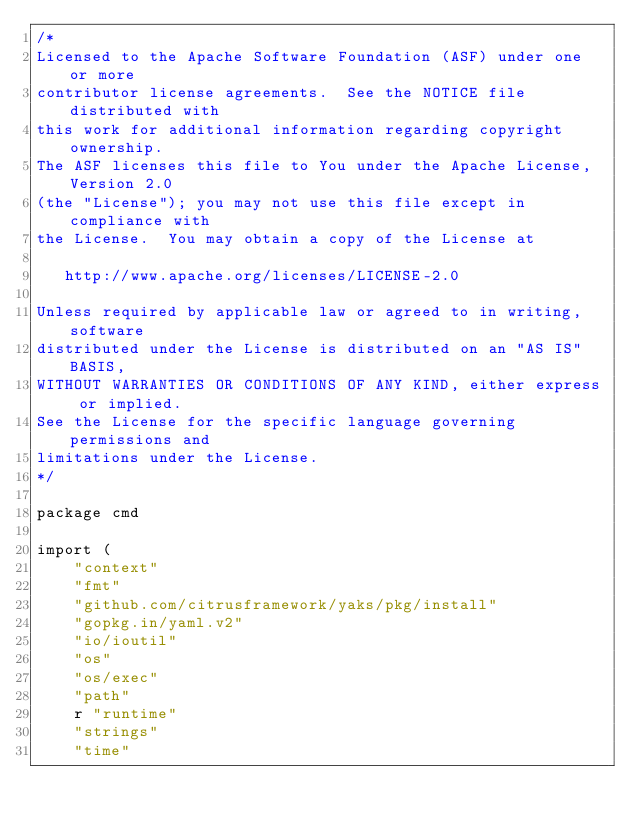Convert code to text. <code><loc_0><loc_0><loc_500><loc_500><_Go_>/*
Licensed to the Apache Software Foundation (ASF) under one or more
contributor license agreements.  See the NOTICE file distributed with
this work for additional information regarding copyright ownership.
The ASF licenses this file to You under the Apache License, Version 2.0
(the "License"); you may not use this file except in compliance with
the License.  You may obtain a copy of the License at

   http://www.apache.org/licenses/LICENSE-2.0

Unless required by applicable law or agreed to in writing, software
distributed under the License is distributed on an "AS IS" BASIS,
WITHOUT WARRANTIES OR CONDITIONS OF ANY KIND, either express or implied.
See the License for the specific language governing permissions and
limitations under the License.
*/

package cmd

import (
	"context"
	"fmt"
	"github.com/citrusframework/yaks/pkg/install"
	"gopkg.in/yaml.v2"
	"io/ioutil"
	"os"
	"os/exec"
	"path"
	r "runtime"
	"strings"
	"time"
</code> 